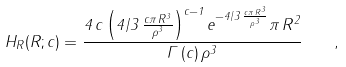Convert formula to latex. <formula><loc_0><loc_0><loc_500><loc_500>H _ { R } ( R ; c ) = \frac { 4 \, c \left ( 4 / 3 \, { \frac { c \pi \, { R } ^ { 3 } } { { \rho } ^ { 3 } } } \right ) ^ { c - 1 } { e ^ { - 4 / 3 \, { \frac { c \pi \, { R } ^ { 3 } } { { \rho } ^ { 3 } } } } } \pi \, { R } ^ { 2 } } { \Gamma \left ( c \right ) { \rho } ^ { 3 } } \quad ,</formula> 